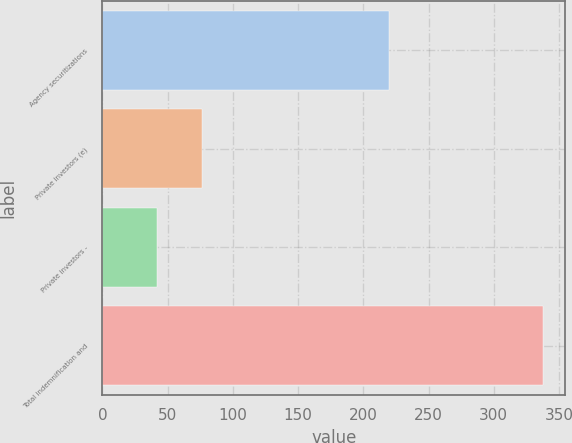<chart> <loc_0><loc_0><loc_500><loc_500><bar_chart><fcel>Agency securitizations<fcel>Private investors (e)<fcel>Private investors -<fcel>Total indemnification and<nl><fcel>220<fcel>76<fcel>42<fcel>338<nl></chart> 